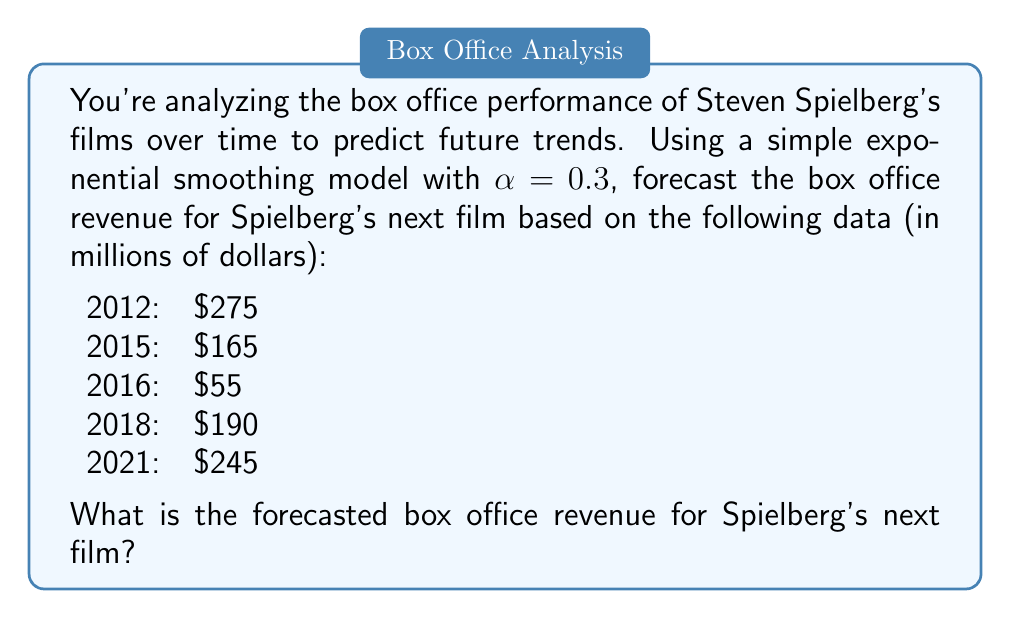Can you solve this math problem? To forecast the box office revenue using simple exponential smoothing, we'll follow these steps:

1) The formula for simple exponential smoothing is:

   $$F_{t+1} = \alpha Y_t + (1-\alpha)F_t$$

   Where:
   - $F_{t+1}$ is the forecast for the next period
   - $\alpha$ is the smoothing factor (given as 0.3)
   - $Y_t$ is the actual value at time t
   - $F_t$ is the forecast for the current period

2) We'll start with the first actual value as our initial forecast:

   $F_{2012} = 275$

3) Now we'll calculate each subsequent forecast:

   For 2015:
   $$F_{2015} = 0.3(275) + 0.7(275) = 275$$

   For 2016:
   $$F_{2016} = 0.3(165) + 0.7(275) = 242$$

   For 2018:
   $$F_{2018} = 0.3(55) + 0.7(242) = 186.4$$

   For 2021:
   $$F_{2021} = 0.3(190) + 0.7(186.4) = 187.48$$

4) Finally, we can forecast for the next film:

   $$F_{next} = 0.3(245) + 0.7(187.48) = 204.74$$
Answer: $204.74 million 